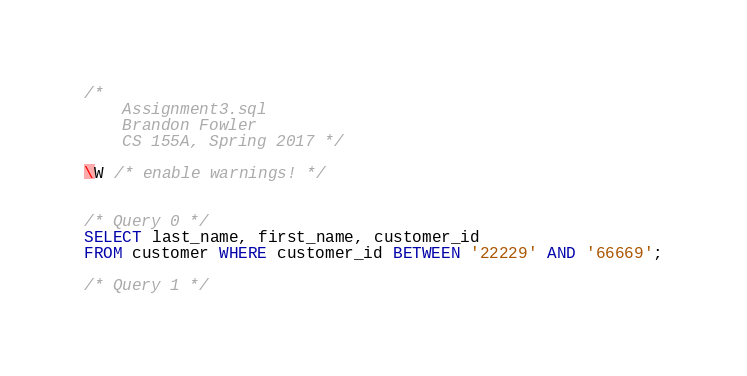Convert code to text. <code><loc_0><loc_0><loc_500><loc_500><_SQL_>/* 
 	Assignment3.sql
	Brandon Fowler
	CS 155A, Spring 2017 */

\W /* enable warnings! */


/* Query 0 */
SELECT last_name, first_name, customer_id 
FROM customer WHERE customer_id BETWEEN '22229' AND '66669';

/* Query 1 */</code> 